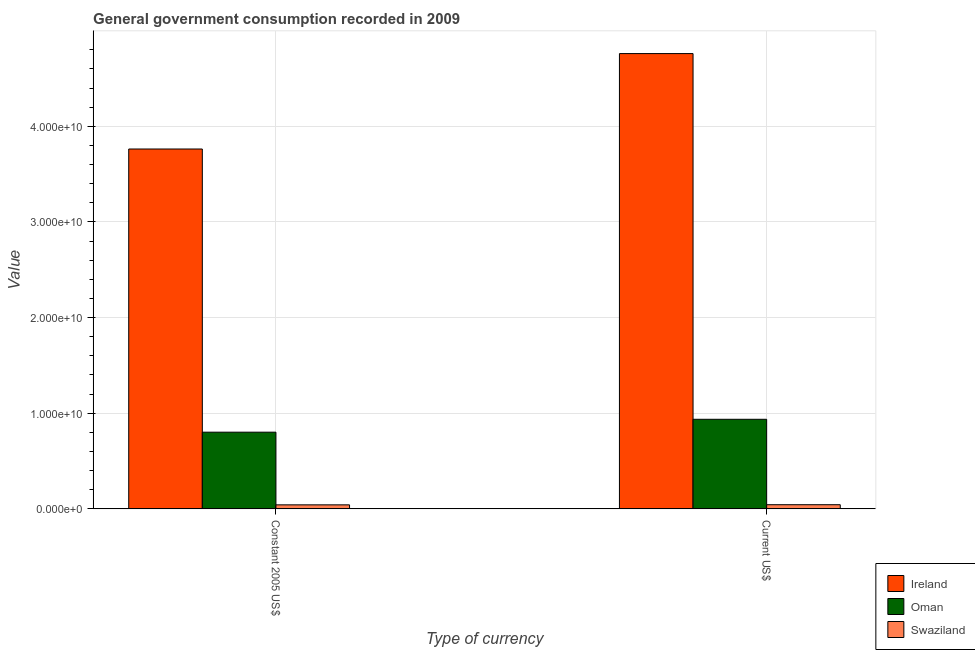How many different coloured bars are there?
Your answer should be compact. 3. How many groups of bars are there?
Give a very brief answer. 2. Are the number of bars per tick equal to the number of legend labels?
Provide a short and direct response. Yes. Are the number of bars on each tick of the X-axis equal?
Offer a very short reply. Yes. How many bars are there on the 2nd tick from the left?
Ensure brevity in your answer.  3. How many bars are there on the 1st tick from the right?
Provide a succinct answer. 3. What is the label of the 2nd group of bars from the left?
Your answer should be very brief. Current US$. What is the value consumed in current us$ in Oman?
Your answer should be compact. 9.37e+09. Across all countries, what is the maximum value consumed in current us$?
Your response must be concise. 4.76e+1. Across all countries, what is the minimum value consumed in constant 2005 us$?
Give a very brief answer. 4.18e+08. In which country was the value consumed in constant 2005 us$ maximum?
Provide a short and direct response. Ireland. In which country was the value consumed in constant 2005 us$ minimum?
Keep it short and to the point. Swaziland. What is the total value consumed in current us$ in the graph?
Keep it short and to the point. 5.74e+1. What is the difference between the value consumed in current us$ in Oman and that in Ireland?
Your answer should be compact. -3.82e+1. What is the difference between the value consumed in current us$ in Swaziland and the value consumed in constant 2005 us$ in Oman?
Your response must be concise. -7.58e+09. What is the average value consumed in constant 2005 us$ per country?
Give a very brief answer. 1.54e+1. What is the difference between the value consumed in current us$ and value consumed in constant 2005 us$ in Swaziland?
Your answer should be compact. 1.47e+07. What is the ratio of the value consumed in constant 2005 us$ in Oman to that in Ireland?
Provide a short and direct response. 0.21. Is the value consumed in constant 2005 us$ in Ireland less than that in Oman?
Your answer should be compact. No. In how many countries, is the value consumed in constant 2005 us$ greater than the average value consumed in constant 2005 us$ taken over all countries?
Provide a succinct answer. 1. What does the 2nd bar from the left in Current US$ represents?
Offer a terse response. Oman. What does the 2nd bar from the right in Constant 2005 US$ represents?
Your response must be concise. Oman. How many bars are there?
Give a very brief answer. 6. How many countries are there in the graph?
Make the answer very short. 3. What is the difference between two consecutive major ticks on the Y-axis?
Your response must be concise. 1.00e+1. Are the values on the major ticks of Y-axis written in scientific E-notation?
Keep it short and to the point. Yes. Does the graph contain grids?
Give a very brief answer. Yes. How many legend labels are there?
Provide a short and direct response. 3. What is the title of the graph?
Keep it short and to the point. General government consumption recorded in 2009. What is the label or title of the X-axis?
Make the answer very short. Type of currency. What is the label or title of the Y-axis?
Give a very brief answer. Value. What is the Value in Ireland in Constant 2005 US$?
Keep it short and to the point. 3.76e+1. What is the Value of Oman in Constant 2005 US$?
Ensure brevity in your answer.  8.02e+09. What is the Value in Swaziland in Constant 2005 US$?
Keep it short and to the point. 4.18e+08. What is the Value in Ireland in Current US$?
Your response must be concise. 4.76e+1. What is the Value in Oman in Current US$?
Keep it short and to the point. 9.37e+09. What is the Value of Swaziland in Current US$?
Make the answer very short. 4.32e+08. Across all Type of currency, what is the maximum Value of Ireland?
Offer a very short reply. 4.76e+1. Across all Type of currency, what is the maximum Value of Oman?
Your answer should be very brief. 9.37e+09. Across all Type of currency, what is the maximum Value in Swaziland?
Your response must be concise. 4.32e+08. Across all Type of currency, what is the minimum Value of Ireland?
Provide a succinct answer. 3.76e+1. Across all Type of currency, what is the minimum Value of Oman?
Keep it short and to the point. 8.02e+09. Across all Type of currency, what is the minimum Value of Swaziland?
Your response must be concise. 4.18e+08. What is the total Value of Ireland in the graph?
Make the answer very short. 8.52e+1. What is the total Value in Oman in the graph?
Your response must be concise. 1.74e+1. What is the total Value of Swaziland in the graph?
Provide a succinct answer. 8.50e+08. What is the difference between the Value of Ireland in Constant 2005 US$ and that in Current US$?
Your answer should be very brief. -9.98e+09. What is the difference between the Value in Oman in Constant 2005 US$ and that in Current US$?
Offer a terse response. -1.35e+09. What is the difference between the Value of Swaziland in Constant 2005 US$ and that in Current US$?
Offer a terse response. -1.47e+07. What is the difference between the Value of Ireland in Constant 2005 US$ and the Value of Oman in Current US$?
Give a very brief answer. 2.83e+1. What is the difference between the Value of Ireland in Constant 2005 US$ and the Value of Swaziland in Current US$?
Provide a short and direct response. 3.72e+1. What is the difference between the Value in Oman in Constant 2005 US$ and the Value in Swaziland in Current US$?
Ensure brevity in your answer.  7.58e+09. What is the average Value in Ireland per Type of currency?
Your answer should be compact. 4.26e+1. What is the average Value in Oman per Type of currency?
Offer a very short reply. 8.69e+09. What is the average Value in Swaziland per Type of currency?
Provide a short and direct response. 4.25e+08. What is the difference between the Value of Ireland and Value of Oman in Constant 2005 US$?
Ensure brevity in your answer.  2.96e+1. What is the difference between the Value in Ireland and Value in Swaziland in Constant 2005 US$?
Your response must be concise. 3.72e+1. What is the difference between the Value of Oman and Value of Swaziland in Constant 2005 US$?
Offer a very short reply. 7.60e+09. What is the difference between the Value of Ireland and Value of Oman in Current US$?
Your answer should be compact. 3.82e+1. What is the difference between the Value in Ireland and Value in Swaziland in Current US$?
Offer a very short reply. 4.72e+1. What is the difference between the Value of Oman and Value of Swaziland in Current US$?
Provide a succinct answer. 8.93e+09. What is the ratio of the Value of Ireland in Constant 2005 US$ to that in Current US$?
Provide a succinct answer. 0.79. What is the ratio of the Value of Oman in Constant 2005 US$ to that in Current US$?
Your answer should be very brief. 0.86. What is the ratio of the Value in Swaziland in Constant 2005 US$ to that in Current US$?
Your answer should be very brief. 0.97. What is the difference between the highest and the second highest Value of Ireland?
Offer a terse response. 9.98e+09. What is the difference between the highest and the second highest Value of Oman?
Your answer should be very brief. 1.35e+09. What is the difference between the highest and the second highest Value of Swaziland?
Your response must be concise. 1.47e+07. What is the difference between the highest and the lowest Value in Ireland?
Offer a terse response. 9.98e+09. What is the difference between the highest and the lowest Value of Oman?
Your answer should be compact. 1.35e+09. What is the difference between the highest and the lowest Value of Swaziland?
Keep it short and to the point. 1.47e+07. 